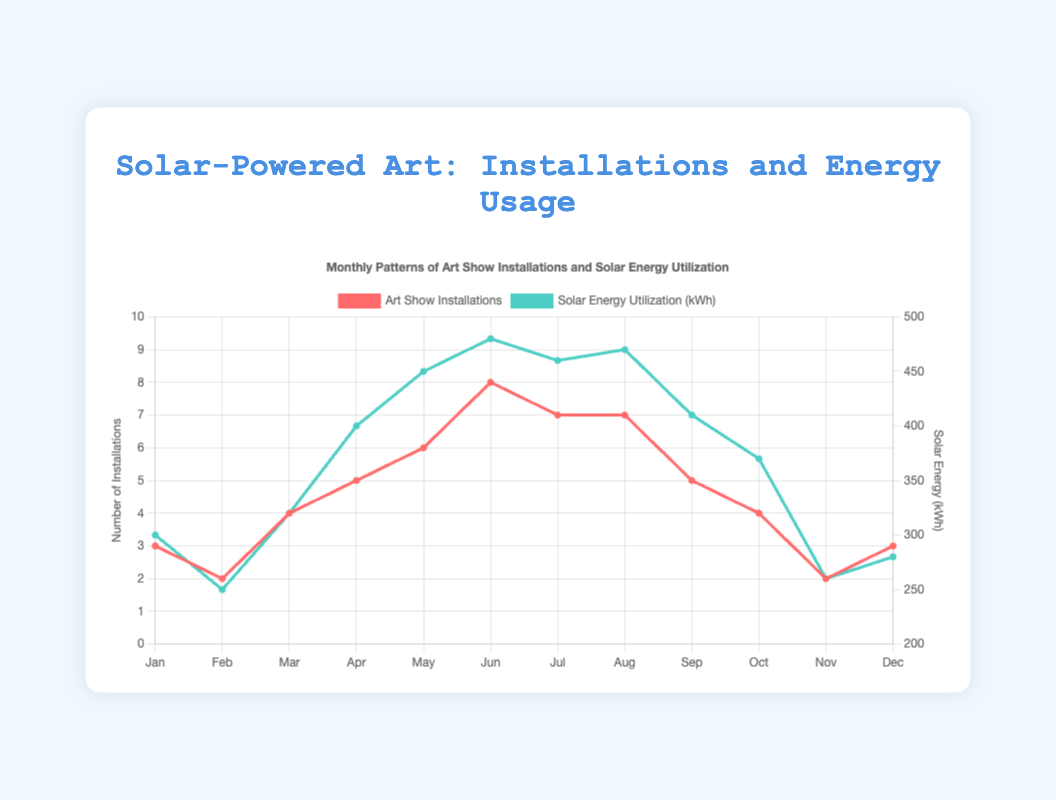Which month had the highest number of art show installations? Look at the line for the number of art show installations. The peak is in June, with 8 installations.
Answer: June What is the difference in solar energy utilization between May and September? Solar energy utilization in May is 450 kWh, and in September, it is 410 kWh. The difference is 450 - 410 = 40 kWh.
Answer: 40 kWh During which months are the art show installations equal in number? Check the line for art show installations and find equal values. Both July and August have 7 installations, January and December have 3 installations, and February and November have 2 installations.
Answer: July and August, January and December, February and November How does the solar energy utilization in March compare to that in October? In March, solar energy utilization is 320 kWh, and in October, it is 370 kWh. Since 370 > 320, October has higher utilization.
Answer: October has higher utilization What is the average number of art show installations over the year? Sum all installations (3 + 2 + 4 + 5 + 6 + 8 + 7 + 7 + 5 + 4 + 2 + 3 = 56) and divide by 12 months. The average is 56 / 12 ≈ 4.67.
Answer: 4.67 installations Which month had the lowest solar energy utilization, and how much was it? Check the line for solar energy utilization. February had the lowest, at 250 kWh.
Answer: February, 250 kWh Is there a month with both the highest art show installations and solar energy utilization? The month with the highest art show installations is June (8), and solar energy utilization is 480 kWh. Both values are the highest in respective categories.
Answer: Yes, June Is there any month where the number of installations and solar energy utilization both decreased compared to the previous month? In July, there were 7 installations and in August also 7, so no change in installations but solar energy increased to 470 kWh from 460 kWh. However, in October, installations decreased to 4 from 5, and energy utilization decreased to 370 kWh from 410 kWh in September.
Answer: October What is the total solar energy utilization over the year? Sum all solar energy utilization values (300 + 250 + 320 + 400 + 450 + 480 + 460 + 470 + 410 + 370 + 260 + 280 = 4450).
Answer: 4450 kWh Compare the change in the number of installations between March and April with the change in solar energy utilization between the same months. The number of installations increased from 4 to 5 (an increase of 1), while solar energy utilization increased from 320 kWh to 400 kWh (an increase of 80 kWh).
Answer: Installations increased by 1, energy by 80 kWh 